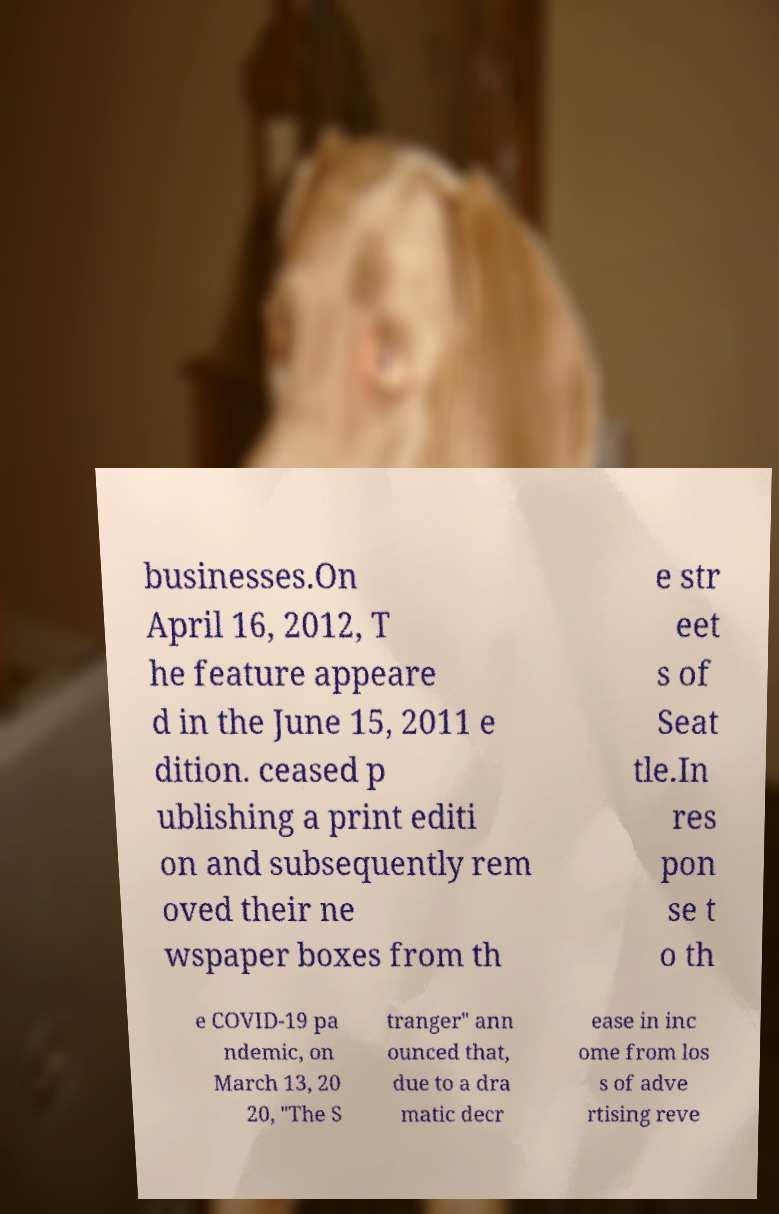For documentation purposes, I need the text within this image transcribed. Could you provide that? businesses.On April 16, 2012, T he feature appeare d in the June 15, 2011 e dition. ceased p ublishing a print editi on and subsequently rem oved their ne wspaper boxes from th e str eet s of Seat tle.In res pon se t o th e COVID-19 pa ndemic, on March 13, 20 20, "The S tranger" ann ounced that, due to a dra matic decr ease in inc ome from los s of adve rtising reve 